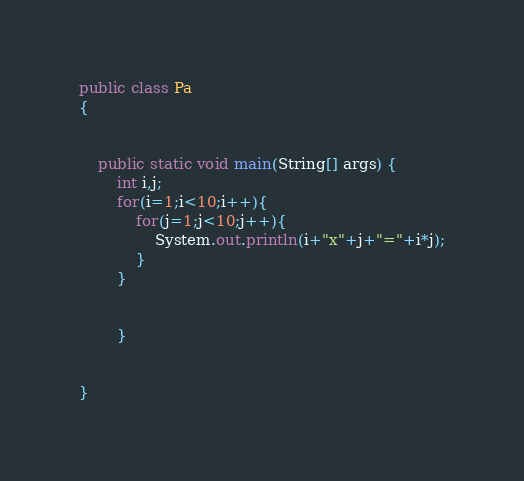<code> <loc_0><loc_0><loc_500><loc_500><_Java_>public class Pa
{


	public static void main(String[] args) {
		int i,j;
		for(i=1;i<10;i++){
			for(j=1;j<10;j++){
				System.out.println(i+"x"+j+"="+i*j);
			}
		}
		
					
		}
	

}</code> 